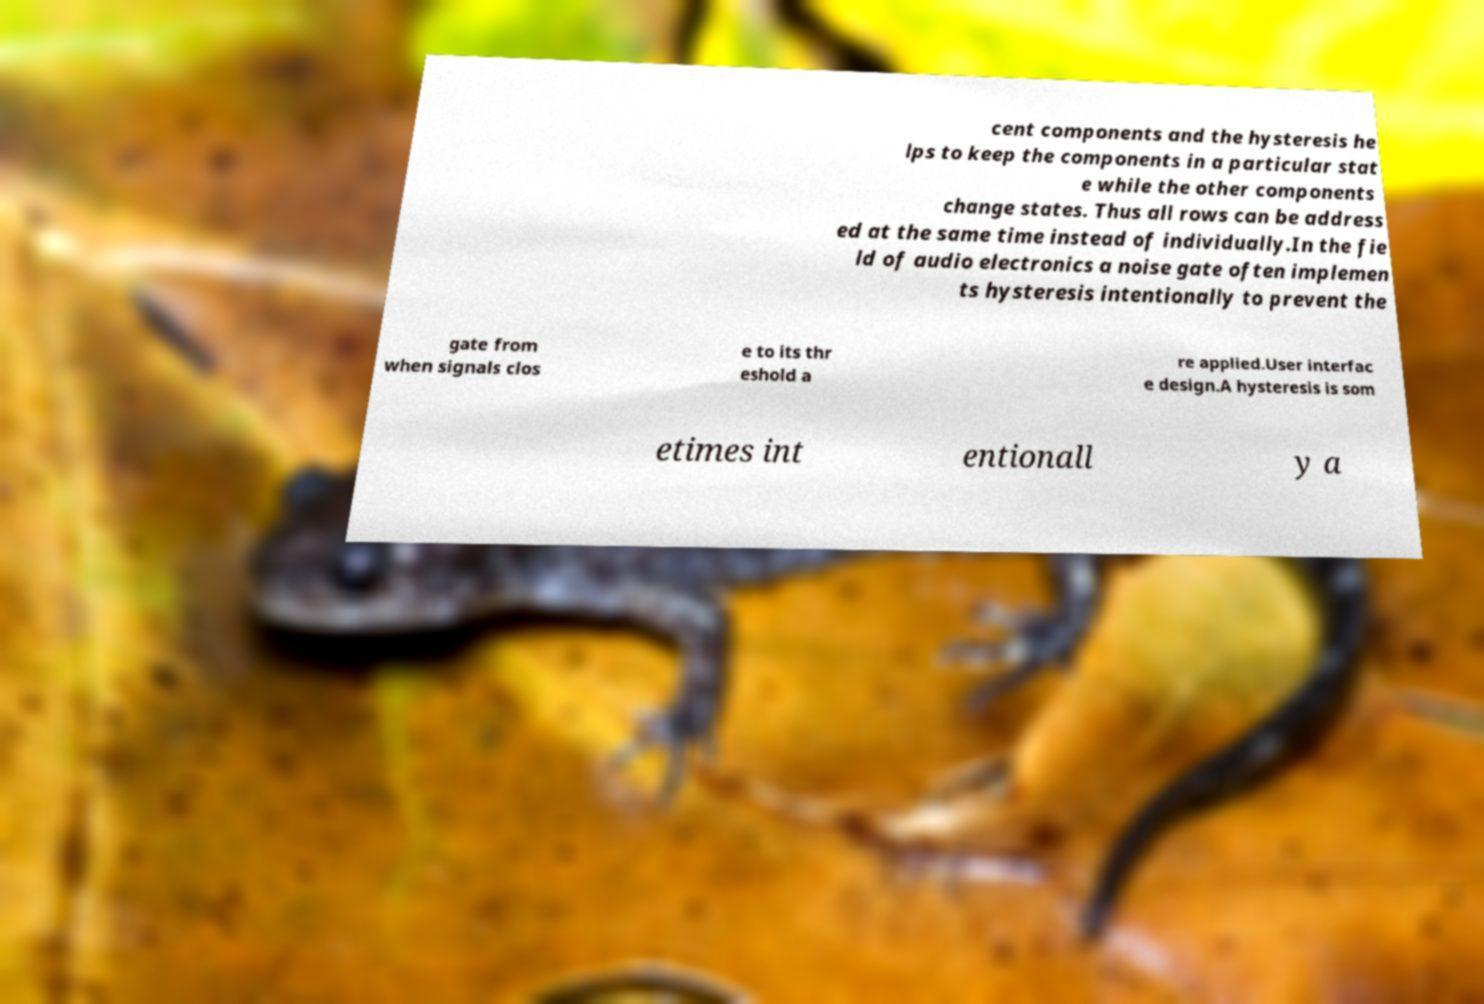Please read and relay the text visible in this image. What does it say? cent components and the hysteresis he lps to keep the components in a particular stat e while the other components change states. Thus all rows can be address ed at the same time instead of individually.In the fie ld of audio electronics a noise gate often implemen ts hysteresis intentionally to prevent the gate from when signals clos e to its thr eshold a re applied.User interfac e design.A hysteresis is som etimes int entionall y a 